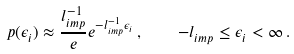Convert formula to latex. <formula><loc_0><loc_0><loc_500><loc_500>p ( \epsilon _ { i } ) \approx \frac { l _ { i m p } ^ { - 1 } } { e } e ^ { - l _ { i m p } ^ { - 1 } \epsilon _ { i } } \, , \quad - l _ { i m p } \leq \epsilon _ { i } < \infty \, .</formula> 